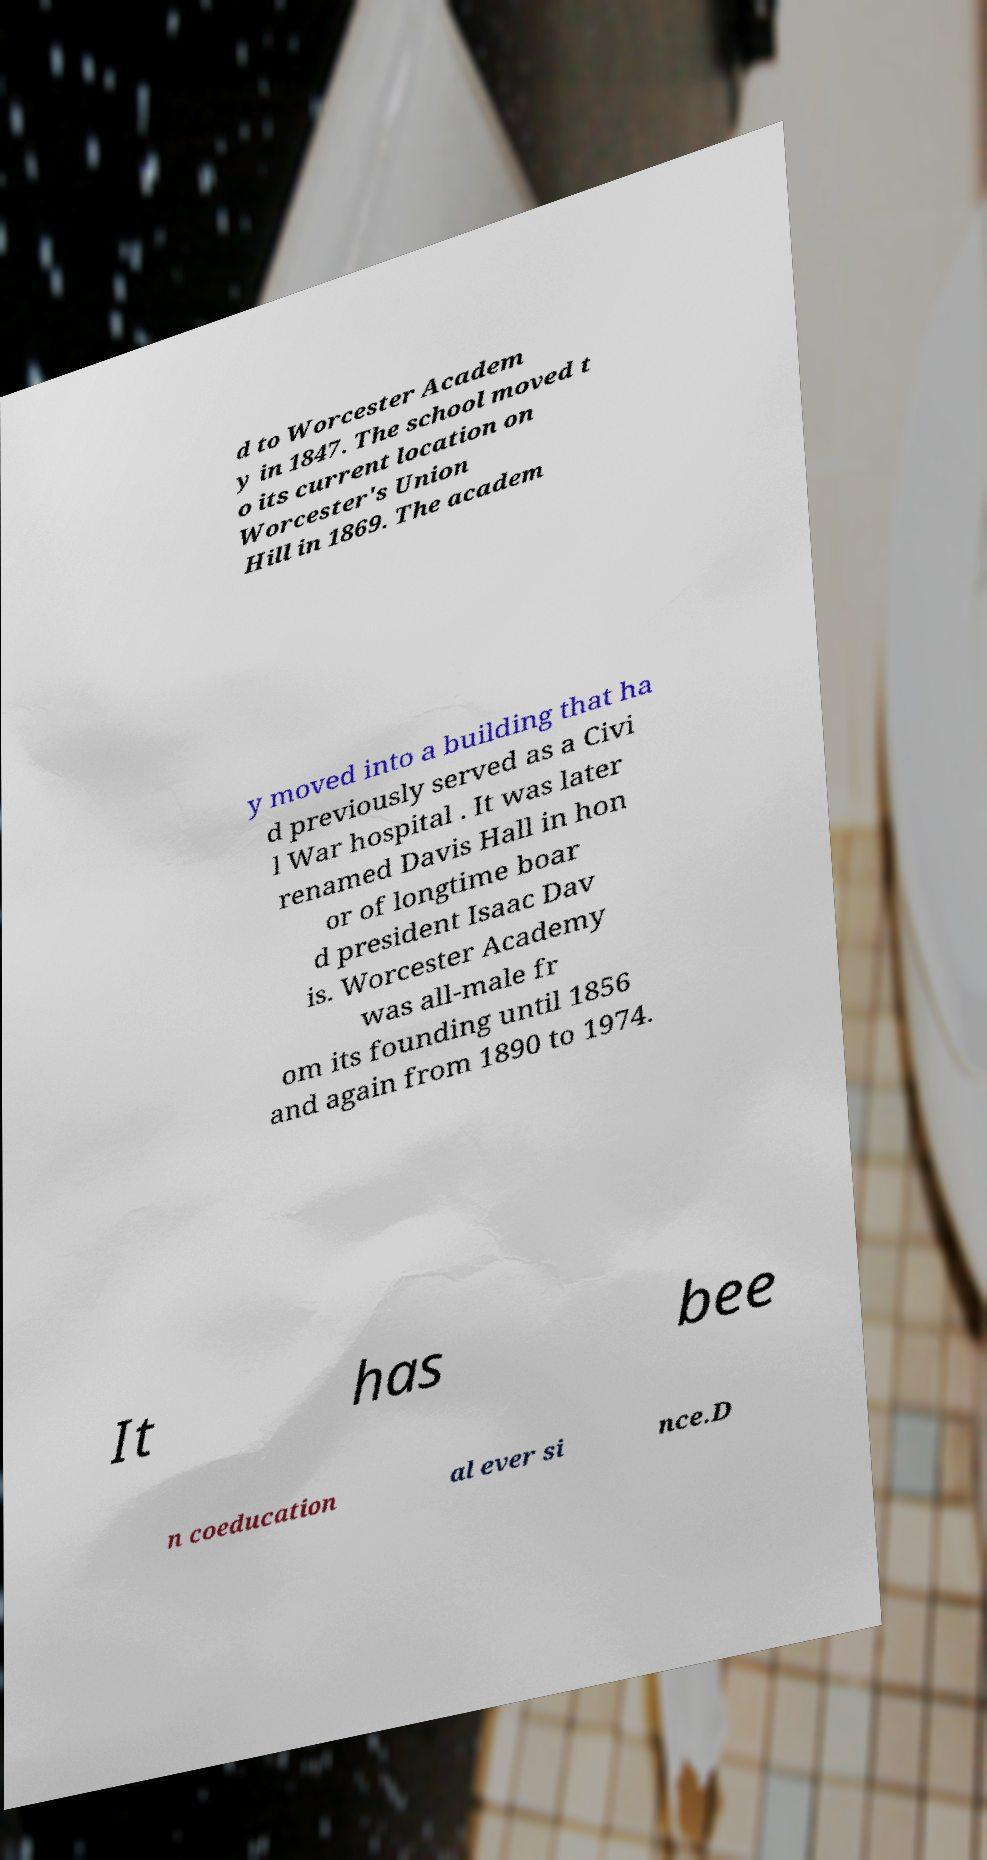Could you extract and type out the text from this image? d to Worcester Academ y in 1847. The school moved t o its current location on Worcester's Union Hill in 1869. The academ y moved into a building that ha d previously served as a Civi l War hospital . It was later renamed Davis Hall in hon or of longtime boar d president Isaac Dav is. Worcester Academy was all-male fr om its founding until 1856 and again from 1890 to 1974. It has bee n coeducation al ever si nce.D 